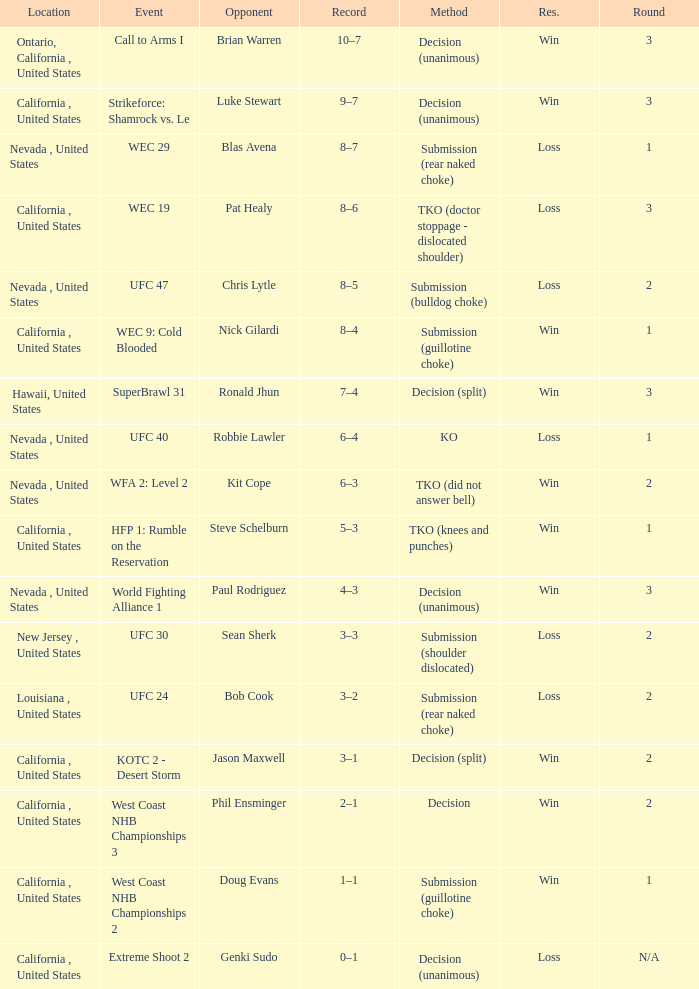I'm looking to parse the entire table for insights. Could you assist me with that? {'header': ['Location', 'Event', 'Opponent', 'Record', 'Method', 'Res.', 'Round'], 'rows': [['Ontario, California , United States', 'Call to Arms I', 'Brian Warren', '10–7', 'Decision (unanimous)', 'Win', '3'], ['California , United States', 'Strikeforce: Shamrock vs. Le', 'Luke Stewart', '9–7', 'Decision (unanimous)', 'Win', '3'], ['Nevada , United States', 'WEC 29', 'Blas Avena', '8–7', 'Submission (rear naked choke)', 'Loss', '1'], ['California , United States', 'WEC 19', 'Pat Healy', '8–6', 'TKO (doctor stoppage - dislocated shoulder)', 'Loss', '3'], ['Nevada , United States', 'UFC 47', 'Chris Lytle', '8–5', 'Submission (bulldog choke)', 'Loss', '2'], ['California , United States', 'WEC 9: Cold Blooded', 'Nick Gilardi', '8–4', 'Submission (guillotine choke)', 'Win', '1'], ['Hawaii, United States', 'SuperBrawl 31', 'Ronald Jhun', '7–4', 'Decision (split)', 'Win', '3'], ['Nevada , United States', 'UFC 40', 'Robbie Lawler', '6–4', 'KO', 'Loss', '1'], ['Nevada , United States', 'WFA 2: Level 2', 'Kit Cope', '6–3', 'TKO (did not answer bell)', 'Win', '2'], ['California , United States', 'HFP 1: Rumble on the Reservation', 'Steve Schelburn', '5–3', 'TKO (knees and punches)', 'Win', '1'], ['Nevada , United States', 'World Fighting Alliance 1', 'Paul Rodriguez', '4–3', 'Decision (unanimous)', 'Win', '3'], ['New Jersey , United States', 'UFC 30', 'Sean Sherk', '3–3', 'Submission (shoulder dislocated)', 'Loss', '2'], ['Louisiana , United States', 'UFC 24', 'Bob Cook', '3–2', 'Submission (rear naked choke)', 'Loss', '2'], ['California , United States', 'KOTC 2 - Desert Storm', 'Jason Maxwell', '3–1', 'Decision (split)', 'Win', '2'], ['California , United States', 'West Coast NHB Championships 3', 'Phil Ensminger', '2–1', 'Decision', 'Win', '2'], ['California , United States', 'West Coast NHB Championships 2', 'Doug Evans', '1–1', 'Submission (guillotine choke)', 'Win', '1'], ['California , United States', 'Extreme Shoot 2', 'Genki Sudo', '0–1', 'Decision (unanimous)', 'Loss', 'N/A']]} What is the result for the Call to Arms I event? Win. 